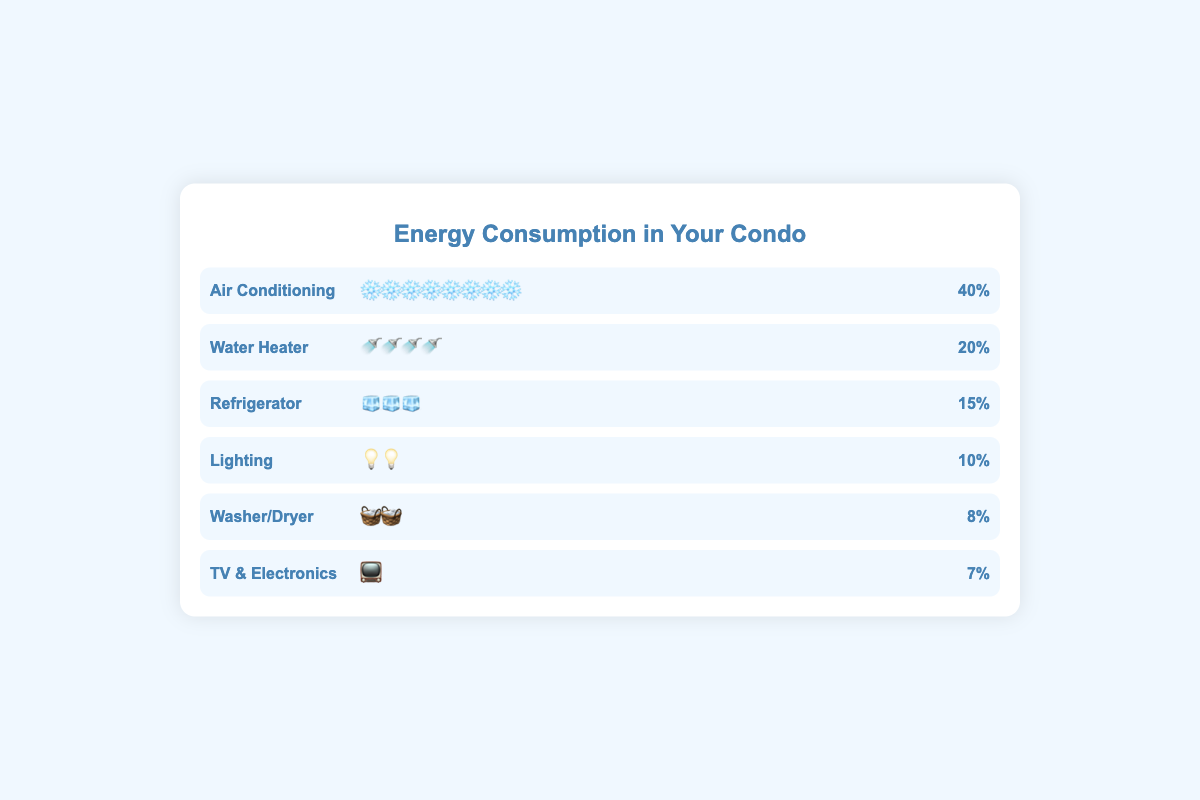what is the title of the plot? The title is seen at the top center of the plot. It reads "Energy Consumption in Your Condo."
Answer: Energy Consumption in Your Condo which appliance type consumes the most energy? Referring to the percentage values shown, "Air Conditioning" has the largest percentage of energy consumption at 40%.
Answer: Air Conditioning how many appliance types are displayed in the plot? Listing each appliance type shown in the plot: Air Conditioning, Water Heater, Refrigerator, Lighting, Washer/Dryer, TV & Electronics, we count a total of 6.
Answer: 6 what percent of energy does the Water Heater consume? Looking at the "Water Heater" row, the percentage displayed is 20%.
Answer: 20% which appliance uses less energy: Washer/Dryer or TV & Electronics? Comparing the percentages, Washer/Dryer consumes 8% and TV & Electronics consumes 7%. Therefore, TV & Electronics uses less energy.
Answer: TV & Electronics what is the total energy consumption of Refrigerators and Lighting combined? Refrigerators consume 15% and Lighting consumes 10%, so 15% + 10% equals a total of 25% combined consumption.
Answer: 25% how many icon elements are shown for Air Conditioning? Each "❄️" icon represents a portion of energy consumed by Air Conditioning. By counting the icons, there are 8 "❄️" symbols shown.
Answer: 8 which appliance type is represented with the icon "🧊"? Referring to the plot, the icon "🧊" is aligned with the "Refrigerator" appliance type.
Answer: Refrigerator how much more energy does Lighting consume compared to TV & Electronics? Lighting consumes 10%, and TV & Electronics consumes 7%. Subtracting the two percentages, 10% - 7% equals 3% more energy for Lighting.
Answer: 3% which two appliance types consume exactly 10% or less of the energy? Referring to the percentage values, "Lighting" consumes exactly 10% and "TV & Electronics" consumes 7%, which are both 10% or less.
Answer: Lighting, TV & Electronics 